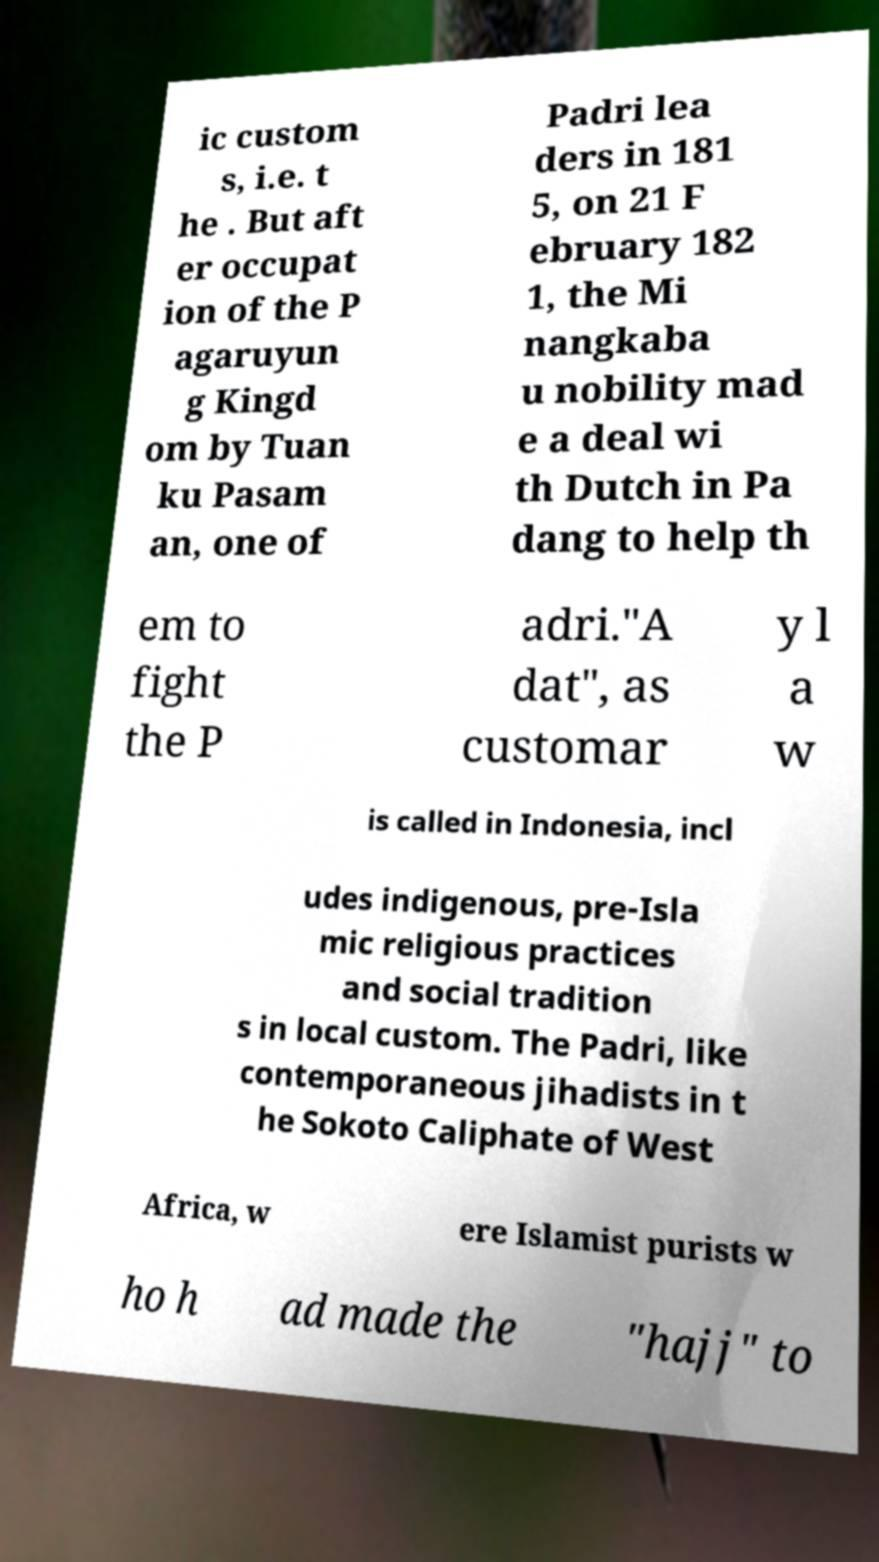Please read and relay the text visible in this image. What does it say? ic custom s, i.e. t he . But aft er occupat ion of the P agaruyun g Kingd om by Tuan ku Pasam an, one of Padri lea ders in 181 5, on 21 F ebruary 182 1, the Mi nangkaba u nobility mad e a deal wi th Dutch in Pa dang to help th em to fight the P adri."A dat", as customar y l a w is called in Indonesia, incl udes indigenous, pre-Isla mic religious practices and social tradition s in local custom. The Padri, like contemporaneous jihadists in t he Sokoto Caliphate of West Africa, w ere Islamist purists w ho h ad made the "hajj" to 